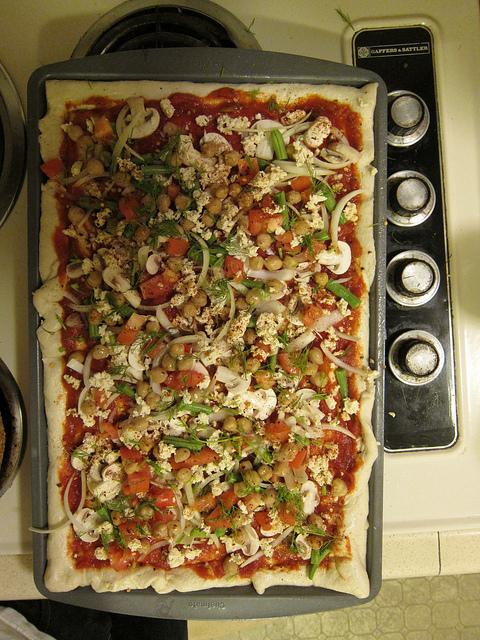Which way is the photo oriented?
Short answer required. Vertical. What is the pizza sitting on?
Quick response, please. Pan. Has the pizza been cooked?
Answer briefly. No. What kind of pizza is that?
Be succinct. Supreme. Is the pizza round?
Be succinct. No. 